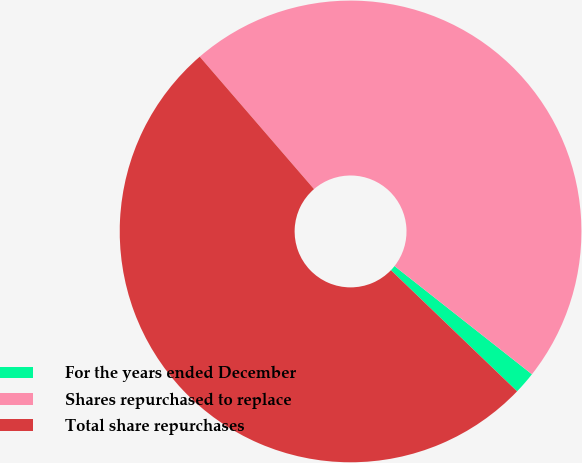Convert chart to OTSL. <chart><loc_0><loc_0><loc_500><loc_500><pie_chart><fcel>For the years ended December<fcel>Shares repurchased to replace<fcel>Total share repurchases<nl><fcel>1.56%<fcel>46.95%<fcel>51.49%<nl></chart> 